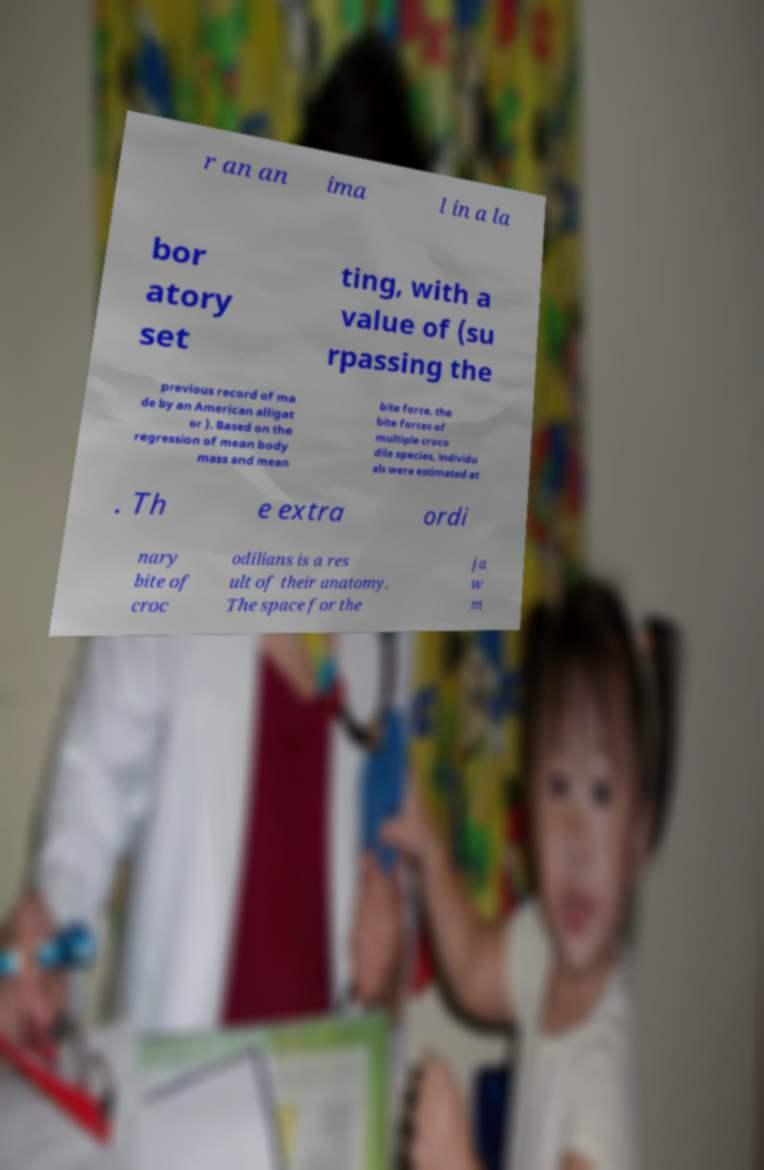What messages or text are displayed in this image? I need them in a readable, typed format. r an an ima l in a la bor atory set ting, with a value of (su rpassing the previous record of ma de by an American alligat or ). Based on the regression of mean body mass and mean bite force, the bite forces of multiple croco dile species, individu als were estimated at . Th e extra ordi nary bite of croc odilians is a res ult of their anatomy. The space for the ja w m 